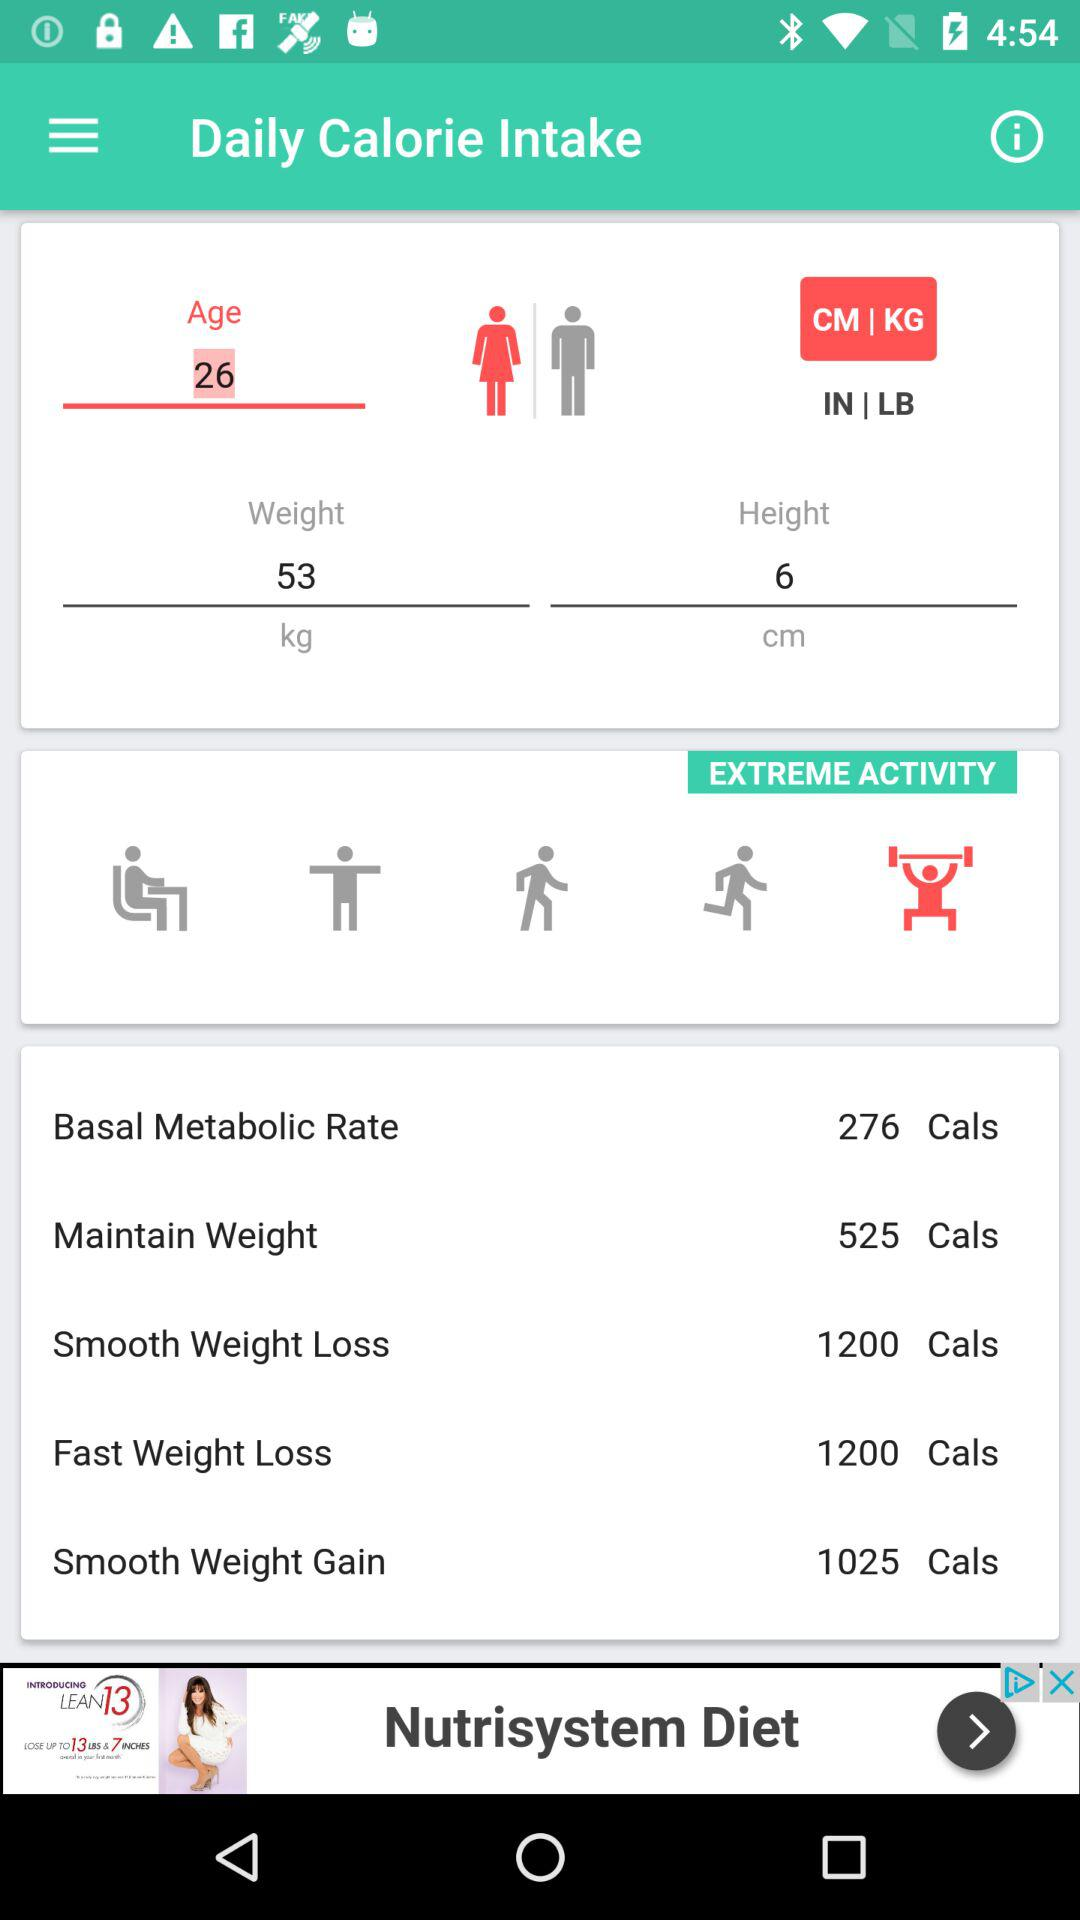What is the count of calories for fast weight loss? The count of calories is 1200. 